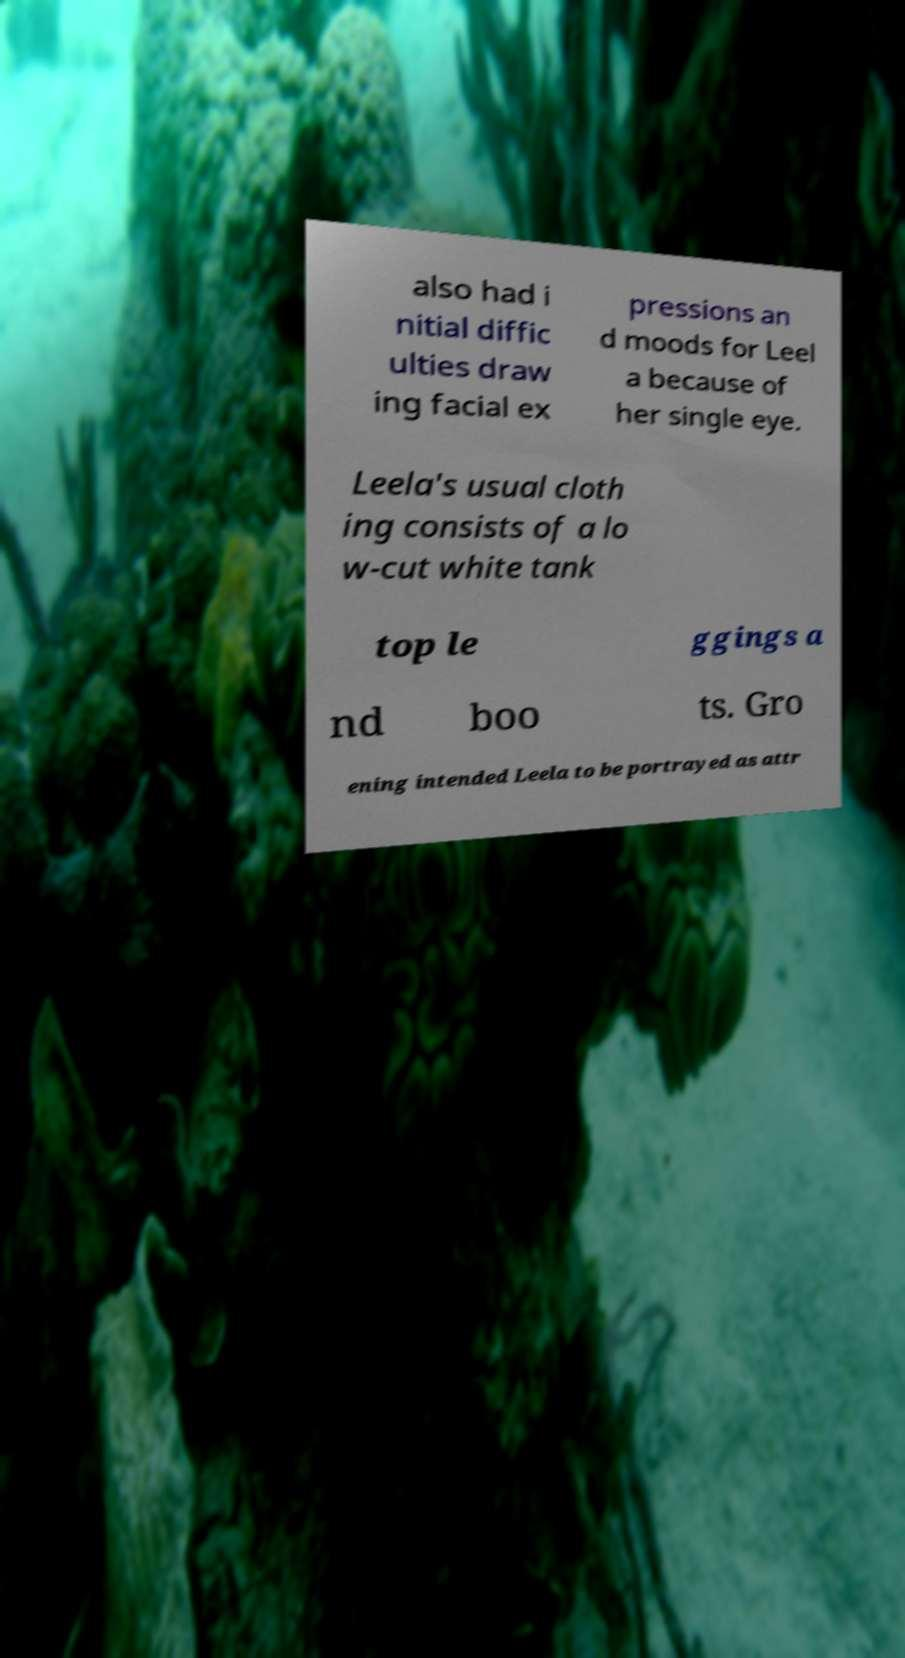I need the written content from this picture converted into text. Can you do that? also had i nitial diffic ulties draw ing facial ex pressions an d moods for Leel a because of her single eye. Leela's usual cloth ing consists of a lo w-cut white tank top le ggings a nd boo ts. Gro ening intended Leela to be portrayed as attr 